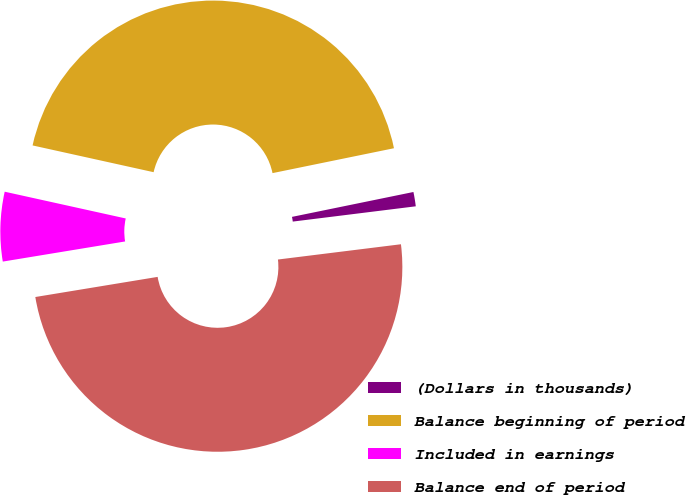Convert chart to OTSL. <chart><loc_0><loc_0><loc_500><loc_500><pie_chart><fcel>(Dollars in thousands)<fcel>Balance beginning of period<fcel>Included in earnings<fcel>Balance end of period<nl><fcel>1.25%<fcel>43.32%<fcel>6.06%<fcel>49.37%<nl></chart> 